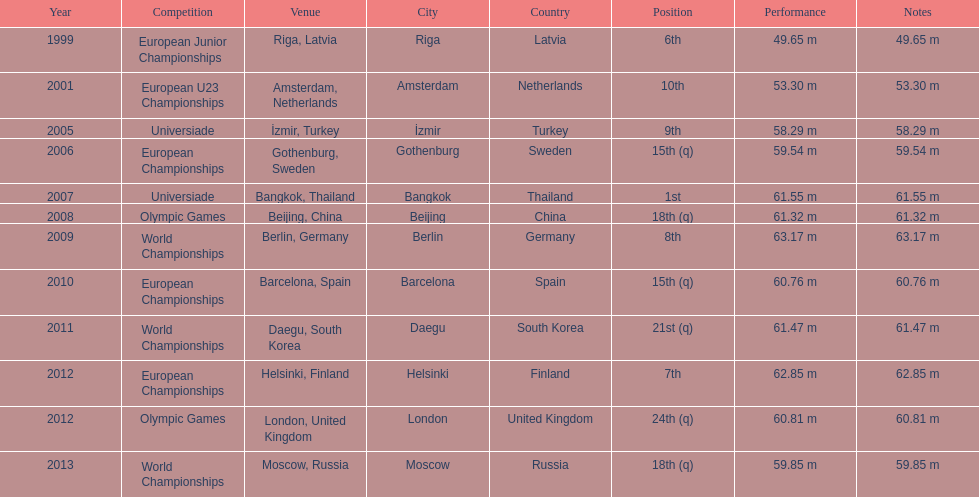Which year held the most competitions? 2012. 